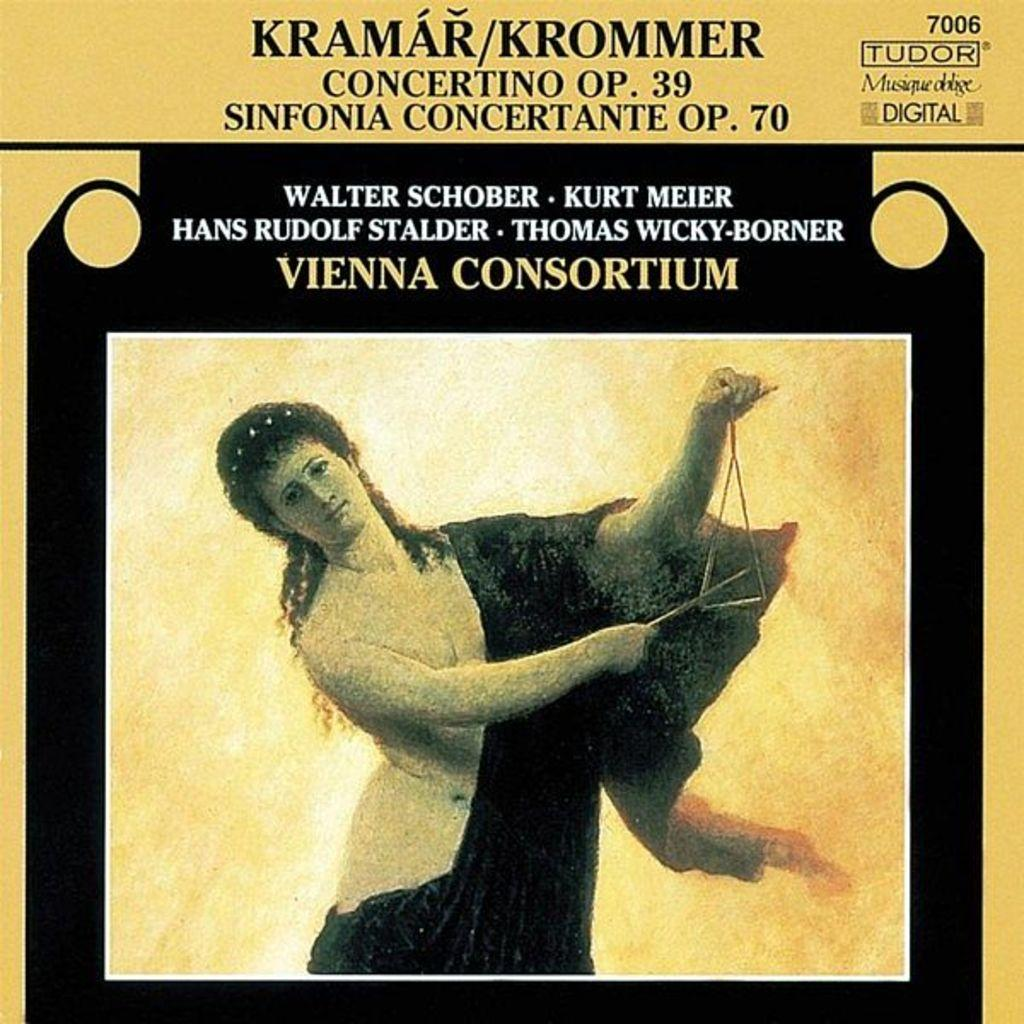What is present on the poster in the image? There is a title and an image of a woman on the poster in the image. Can you describe the image of the woman on the poster? The image of the woman on the poster is not described in the provided facts, so we cannot provide a detailed description. What is the title on the poster? The title on the poster is not mentioned in the provided facts, so we cannot provide the title. How many insects are crawling on the shelf in the image? There is no shelf or insects present in the image; it only features a poster with a title and an image of a woman. 